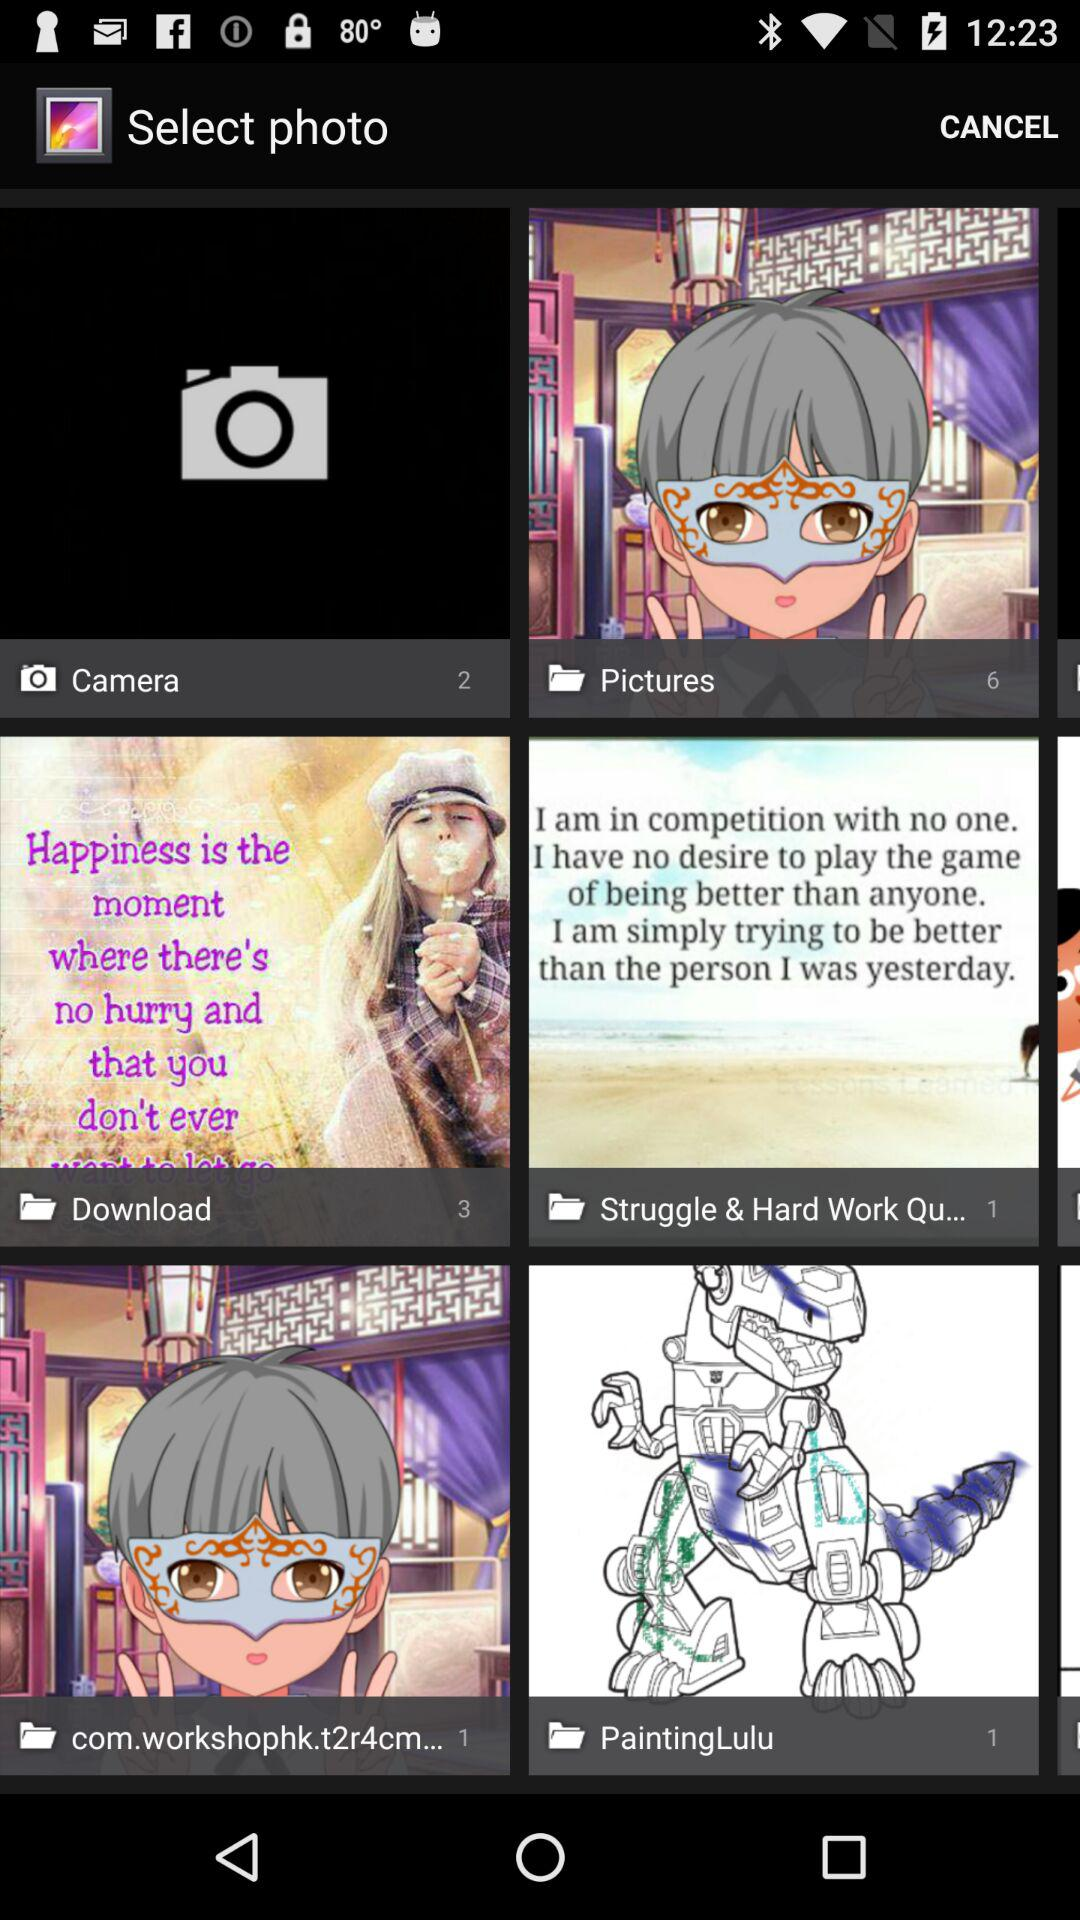What is the total number of images in the "Pictures" folder? The total number of images is 6. 